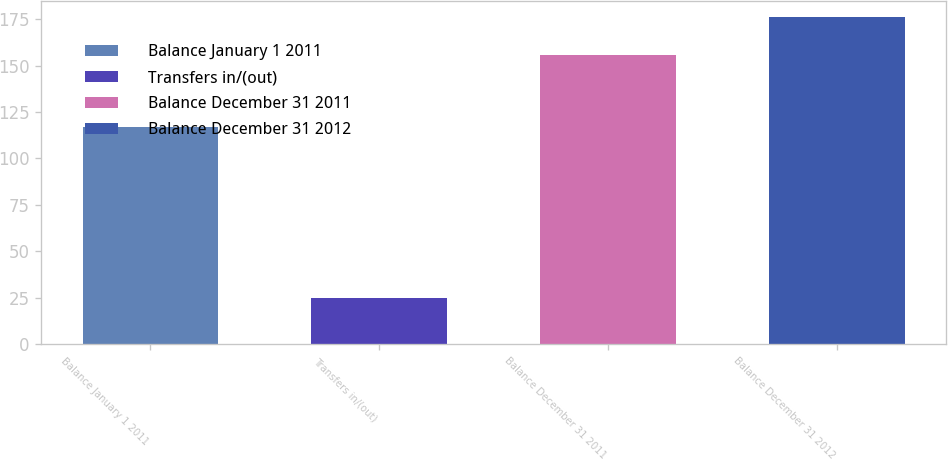Convert chart to OTSL. <chart><loc_0><loc_0><loc_500><loc_500><bar_chart><fcel>Balance January 1 2011<fcel>Transfers in/(out)<fcel>Balance December 31 2011<fcel>Balance December 31 2012<nl><fcel>117<fcel>25<fcel>156<fcel>176<nl></chart> 